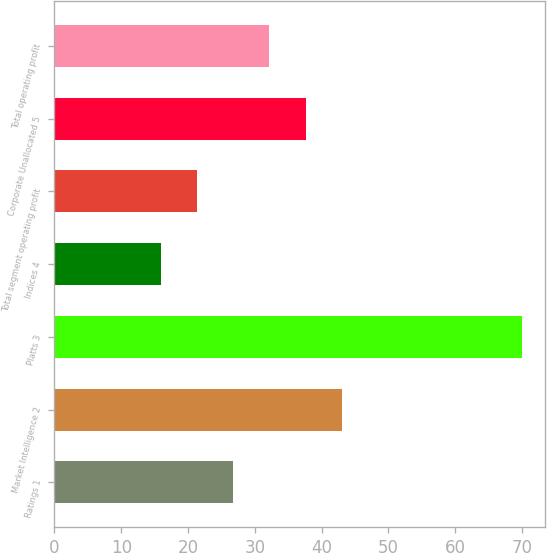Convert chart. <chart><loc_0><loc_0><loc_500><loc_500><bar_chart><fcel>Ratings 1<fcel>Market Intelligence 2<fcel>Platts 3<fcel>Indices 4<fcel>Total segment operating profit<fcel>Corporate Unallocated 5<fcel>Total operating profit<nl><fcel>26.8<fcel>43<fcel>70<fcel>16<fcel>21.4<fcel>37.6<fcel>32.2<nl></chart> 